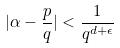<formula> <loc_0><loc_0><loc_500><loc_500>| \alpha - \frac { p } { q } | < \frac { 1 } { q ^ { d + \epsilon } }</formula> 